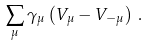<formula> <loc_0><loc_0><loc_500><loc_500>\sum _ { \mu } \gamma _ { \mu } \left ( V _ { \mu } - V _ { - \mu } \right ) \, .</formula> 